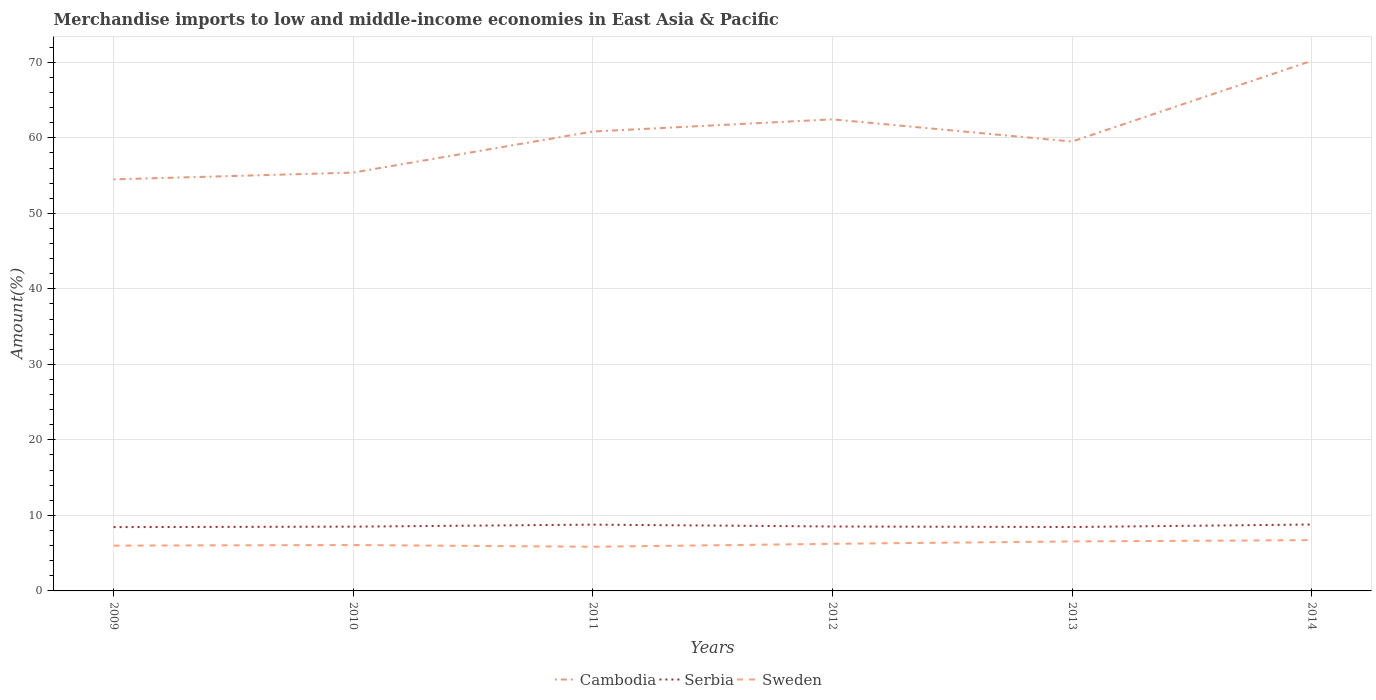How many different coloured lines are there?
Your response must be concise. 3. Is the number of lines equal to the number of legend labels?
Offer a terse response. Yes. Across all years, what is the maximum percentage of amount earned from merchandise imports in Sweden?
Make the answer very short. 5.85. What is the total percentage of amount earned from merchandise imports in Serbia in the graph?
Offer a very short reply. 0.32. What is the difference between the highest and the second highest percentage of amount earned from merchandise imports in Serbia?
Your answer should be very brief. 0.34. What is the difference between the highest and the lowest percentage of amount earned from merchandise imports in Sweden?
Your answer should be very brief. 2. Is the percentage of amount earned from merchandise imports in Serbia strictly greater than the percentage of amount earned from merchandise imports in Sweden over the years?
Ensure brevity in your answer.  No. What is the difference between two consecutive major ticks on the Y-axis?
Ensure brevity in your answer.  10. Are the values on the major ticks of Y-axis written in scientific E-notation?
Provide a short and direct response. No. Does the graph contain any zero values?
Provide a short and direct response. No. Does the graph contain grids?
Provide a short and direct response. Yes. Where does the legend appear in the graph?
Ensure brevity in your answer.  Bottom center. What is the title of the graph?
Your answer should be very brief. Merchandise imports to low and middle-income economies in East Asia & Pacific. Does "Sub-Saharan Africa (all income levels)" appear as one of the legend labels in the graph?
Give a very brief answer. No. What is the label or title of the X-axis?
Provide a succinct answer. Years. What is the label or title of the Y-axis?
Provide a short and direct response. Amount(%). What is the Amount(%) of Cambodia in 2009?
Provide a short and direct response. 54.5. What is the Amount(%) in Serbia in 2009?
Ensure brevity in your answer.  8.45. What is the Amount(%) of Sweden in 2009?
Your answer should be compact. 6. What is the Amount(%) in Cambodia in 2010?
Provide a short and direct response. 55.4. What is the Amount(%) in Serbia in 2010?
Give a very brief answer. 8.51. What is the Amount(%) in Sweden in 2010?
Keep it short and to the point. 6.08. What is the Amount(%) of Cambodia in 2011?
Ensure brevity in your answer.  60.83. What is the Amount(%) in Serbia in 2011?
Make the answer very short. 8.78. What is the Amount(%) of Sweden in 2011?
Make the answer very short. 5.85. What is the Amount(%) of Cambodia in 2012?
Your answer should be compact. 62.45. What is the Amount(%) of Serbia in 2012?
Offer a terse response. 8.53. What is the Amount(%) in Sweden in 2012?
Keep it short and to the point. 6.24. What is the Amount(%) in Cambodia in 2013?
Provide a succinct answer. 59.5. What is the Amount(%) of Serbia in 2013?
Your answer should be compact. 8.46. What is the Amount(%) in Sweden in 2013?
Your response must be concise. 6.55. What is the Amount(%) of Cambodia in 2014?
Your response must be concise. 70.19. What is the Amount(%) of Serbia in 2014?
Offer a very short reply. 8.79. What is the Amount(%) of Sweden in 2014?
Provide a short and direct response. 6.72. Across all years, what is the maximum Amount(%) of Cambodia?
Offer a terse response. 70.19. Across all years, what is the maximum Amount(%) of Serbia?
Make the answer very short. 8.79. Across all years, what is the maximum Amount(%) in Sweden?
Keep it short and to the point. 6.72. Across all years, what is the minimum Amount(%) of Cambodia?
Your response must be concise. 54.5. Across all years, what is the minimum Amount(%) of Serbia?
Your answer should be very brief. 8.45. Across all years, what is the minimum Amount(%) of Sweden?
Give a very brief answer. 5.85. What is the total Amount(%) in Cambodia in the graph?
Provide a short and direct response. 362.88. What is the total Amount(%) in Serbia in the graph?
Keep it short and to the point. 51.53. What is the total Amount(%) of Sweden in the graph?
Provide a succinct answer. 37.44. What is the difference between the Amount(%) of Cambodia in 2009 and that in 2010?
Provide a succinct answer. -0.9. What is the difference between the Amount(%) of Serbia in 2009 and that in 2010?
Keep it short and to the point. -0.06. What is the difference between the Amount(%) of Sweden in 2009 and that in 2010?
Make the answer very short. -0.08. What is the difference between the Amount(%) of Cambodia in 2009 and that in 2011?
Give a very brief answer. -6.33. What is the difference between the Amount(%) in Serbia in 2009 and that in 2011?
Provide a short and direct response. -0.33. What is the difference between the Amount(%) of Sweden in 2009 and that in 2011?
Make the answer very short. 0.15. What is the difference between the Amount(%) in Cambodia in 2009 and that in 2012?
Provide a short and direct response. -7.95. What is the difference between the Amount(%) in Serbia in 2009 and that in 2012?
Ensure brevity in your answer.  -0.08. What is the difference between the Amount(%) in Sweden in 2009 and that in 2012?
Give a very brief answer. -0.24. What is the difference between the Amount(%) of Cambodia in 2009 and that in 2013?
Offer a terse response. -5.01. What is the difference between the Amount(%) in Serbia in 2009 and that in 2013?
Your answer should be very brief. -0.01. What is the difference between the Amount(%) in Sweden in 2009 and that in 2013?
Offer a terse response. -0.55. What is the difference between the Amount(%) in Cambodia in 2009 and that in 2014?
Give a very brief answer. -15.69. What is the difference between the Amount(%) of Serbia in 2009 and that in 2014?
Keep it short and to the point. -0.34. What is the difference between the Amount(%) of Sweden in 2009 and that in 2014?
Provide a succinct answer. -0.72. What is the difference between the Amount(%) in Cambodia in 2010 and that in 2011?
Your answer should be very brief. -5.44. What is the difference between the Amount(%) of Serbia in 2010 and that in 2011?
Offer a very short reply. -0.27. What is the difference between the Amount(%) in Sweden in 2010 and that in 2011?
Offer a terse response. 0.23. What is the difference between the Amount(%) of Cambodia in 2010 and that in 2012?
Offer a very short reply. -7.05. What is the difference between the Amount(%) in Serbia in 2010 and that in 2012?
Your response must be concise. -0.02. What is the difference between the Amount(%) of Sweden in 2010 and that in 2012?
Provide a succinct answer. -0.16. What is the difference between the Amount(%) of Cambodia in 2010 and that in 2013?
Give a very brief answer. -4.11. What is the difference between the Amount(%) of Serbia in 2010 and that in 2013?
Ensure brevity in your answer.  0.05. What is the difference between the Amount(%) in Sweden in 2010 and that in 2013?
Offer a terse response. -0.48. What is the difference between the Amount(%) in Cambodia in 2010 and that in 2014?
Your answer should be very brief. -14.79. What is the difference between the Amount(%) in Serbia in 2010 and that in 2014?
Offer a very short reply. -0.28. What is the difference between the Amount(%) of Sweden in 2010 and that in 2014?
Ensure brevity in your answer.  -0.65. What is the difference between the Amount(%) of Cambodia in 2011 and that in 2012?
Ensure brevity in your answer.  -1.62. What is the difference between the Amount(%) of Serbia in 2011 and that in 2012?
Offer a terse response. 0.25. What is the difference between the Amount(%) in Sweden in 2011 and that in 2012?
Keep it short and to the point. -0.39. What is the difference between the Amount(%) in Cambodia in 2011 and that in 2013?
Ensure brevity in your answer.  1.33. What is the difference between the Amount(%) in Serbia in 2011 and that in 2013?
Your answer should be compact. 0.32. What is the difference between the Amount(%) in Sweden in 2011 and that in 2013?
Offer a very short reply. -0.71. What is the difference between the Amount(%) of Cambodia in 2011 and that in 2014?
Make the answer very short. -9.36. What is the difference between the Amount(%) in Serbia in 2011 and that in 2014?
Give a very brief answer. -0.01. What is the difference between the Amount(%) in Sweden in 2011 and that in 2014?
Make the answer very short. -0.87. What is the difference between the Amount(%) of Cambodia in 2012 and that in 2013?
Your response must be concise. 2.94. What is the difference between the Amount(%) in Serbia in 2012 and that in 2013?
Ensure brevity in your answer.  0.07. What is the difference between the Amount(%) in Sweden in 2012 and that in 2013?
Make the answer very short. -0.32. What is the difference between the Amount(%) of Cambodia in 2012 and that in 2014?
Provide a short and direct response. -7.74. What is the difference between the Amount(%) in Serbia in 2012 and that in 2014?
Your answer should be compact. -0.26. What is the difference between the Amount(%) in Sweden in 2012 and that in 2014?
Give a very brief answer. -0.48. What is the difference between the Amount(%) in Cambodia in 2013 and that in 2014?
Provide a short and direct response. -10.69. What is the difference between the Amount(%) of Serbia in 2013 and that in 2014?
Your answer should be compact. -0.33. What is the difference between the Amount(%) in Sweden in 2013 and that in 2014?
Provide a short and direct response. -0.17. What is the difference between the Amount(%) in Cambodia in 2009 and the Amount(%) in Serbia in 2010?
Ensure brevity in your answer.  45.99. What is the difference between the Amount(%) of Cambodia in 2009 and the Amount(%) of Sweden in 2010?
Provide a short and direct response. 48.42. What is the difference between the Amount(%) of Serbia in 2009 and the Amount(%) of Sweden in 2010?
Offer a very short reply. 2.37. What is the difference between the Amount(%) of Cambodia in 2009 and the Amount(%) of Serbia in 2011?
Your response must be concise. 45.72. What is the difference between the Amount(%) in Cambodia in 2009 and the Amount(%) in Sweden in 2011?
Offer a terse response. 48.65. What is the difference between the Amount(%) in Serbia in 2009 and the Amount(%) in Sweden in 2011?
Keep it short and to the point. 2.6. What is the difference between the Amount(%) in Cambodia in 2009 and the Amount(%) in Serbia in 2012?
Provide a succinct answer. 45.97. What is the difference between the Amount(%) of Cambodia in 2009 and the Amount(%) of Sweden in 2012?
Provide a succinct answer. 48.26. What is the difference between the Amount(%) in Serbia in 2009 and the Amount(%) in Sweden in 2012?
Your answer should be very brief. 2.21. What is the difference between the Amount(%) of Cambodia in 2009 and the Amount(%) of Serbia in 2013?
Your answer should be very brief. 46.04. What is the difference between the Amount(%) of Cambodia in 2009 and the Amount(%) of Sweden in 2013?
Your answer should be compact. 47.95. What is the difference between the Amount(%) in Serbia in 2009 and the Amount(%) in Sweden in 2013?
Your response must be concise. 1.9. What is the difference between the Amount(%) of Cambodia in 2009 and the Amount(%) of Serbia in 2014?
Offer a very short reply. 45.71. What is the difference between the Amount(%) in Cambodia in 2009 and the Amount(%) in Sweden in 2014?
Your answer should be compact. 47.78. What is the difference between the Amount(%) of Serbia in 2009 and the Amount(%) of Sweden in 2014?
Your answer should be very brief. 1.73. What is the difference between the Amount(%) of Cambodia in 2010 and the Amount(%) of Serbia in 2011?
Provide a short and direct response. 46.62. What is the difference between the Amount(%) in Cambodia in 2010 and the Amount(%) in Sweden in 2011?
Provide a succinct answer. 49.55. What is the difference between the Amount(%) of Serbia in 2010 and the Amount(%) of Sweden in 2011?
Provide a succinct answer. 2.66. What is the difference between the Amount(%) of Cambodia in 2010 and the Amount(%) of Serbia in 2012?
Give a very brief answer. 46.87. What is the difference between the Amount(%) of Cambodia in 2010 and the Amount(%) of Sweden in 2012?
Provide a succinct answer. 49.16. What is the difference between the Amount(%) of Serbia in 2010 and the Amount(%) of Sweden in 2012?
Your answer should be very brief. 2.27. What is the difference between the Amount(%) of Cambodia in 2010 and the Amount(%) of Serbia in 2013?
Offer a terse response. 46.93. What is the difference between the Amount(%) in Cambodia in 2010 and the Amount(%) in Sweden in 2013?
Ensure brevity in your answer.  48.84. What is the difference between the Amount(%) of Serbia in 2010 and the Amount(%) of Sweden in 2013?
Ensure brevity in your answer.  1.96. What is the difference between the Amount(%) of Cambodia in 2010 and the Amount(%) of Serbia in 2014?
Your answer should be very brief. 46.6. What is the difference between the Amount(%) of Cambodia in 2010 and the Amount(%) of Sweden in 2014?
Keep it short and to the point. 48.67. What is the difference between the Amount(%) in Serbia in 2010 and the Amount(%) in Sweden in 2014?
Offer a very short reply. 1.79. What is the difference between the Amount(%) of Cambodia in 2011 and the Amount(%) of Serbia in 2012?
Offer a terse response. 52.3. What is the difference between the Amount(%) in Cambodia in 2011 and the Amount(%) in Sweden in 2012?
Your answer should be compact. 54.6. What is the difference between the Amount(%) in Serbia in 2011 and the Amount(%) in Sweden in 2012?
Make the answer very short. 2.54. What is the difference between the Amount(%) in Cambodia in 2011 and the Amount(%) in Serbia in 2013?
Give a very brief answer. 52.37. What is the difference between the Amount(%) in Cambodia in 2011 and the Amount(%) in Sweden in 2013?
Make the answer very short. 54.28. What is the difference between the Amount(%) of Serbia in 2011 and the Amount(%) of Sweden in 2013?
Provide a succinct answer. 2.22. What is the difference between the Amount(%) of Cambodia in 2011 and the Amount(%) of Serbia in 2014?
Your answer should be compact. 52.04. What is the difference between the Amount(%) in Cambodia in 2011 and the Amount(%) in Sweden in 2014?
Ensure brevity in your answer.  54.11. What is the difference between the Amount(%) of Serbia in 2011 and the Amount(%) of Sweden in 2014?
Give a very brief answer. 2.06. What is the difference between the Amount(%) of Cambodia in 2012 and the Amount(%) of Serbia in 2013?
Give a very brief answer. 53.99. What is the difference between the Amount(%) of Cambodia in 2012 and the Amount(%) of Sweden in 2013?
Your answer should be compact. 55.9. What is the difference between the Amount(%) of Serbia in 2012 and the Amount(%) of Sweden in 2013?
Your answer should be very brief. 1.98. What is the difference between the Amount(%) in Cambodia in 2012 and the Amount(%) in Serbia in 2014?
Provide a short and direct response. 53.66. What is the difference between the Amount(%) in Cambodia in 2012 and the Amount(%) in Sweden in 2014?
Provide a succinct answer. 55.73. What is the difference between the Amount(%) in Serbia in 2012 and the Amount(%) in Sweden in 2014?
Offer a terse response. 1.81. What is the difference between the Amount(%) in Cambodia in 2013 and the Amount(%) in Serbia in 2014?
Your response must be concise. 50.71. What is the difference between the Amount(%) in Cambodia in 2013 and the Amount(%) in Sweden in 2014?
Offer a terse response. 52.78. What is the difference between the Amount(%) in Serbia in 2013 and the Amount(%) in Sweden in 2014?
Your answer should be very brief. 1.74. What is the average Amount(%) of Cambodia per year?
Give a very brief answer. 60.48. What is the average Amount(%) in Serbia per year?
Provide a short and direct response. 8.59. What is the average Amount(%) of Sweden per year?
Your answer should be very brief. 6.24. In the year 2009, what is the difference between the Amount(%) in Cambodia and Amount(%) in Serbia?
Make the answer very short. 46.05. In the year 2009, what is the difference between the Amount(%) in Cambodia and Amount(%) in Sweden?
Your answer should be very brief. 48.5. In the year 2009, what is the difference between the Amount(%) in Serbia and Amount(%) in Sweden?
Provide a short and direct response. 2.45. In the year 2010, what is the difference between the Amount(%) in Cambodia and Amount(%) in Serbia?
Offer a very short reply. 46.88. In the year 2010, what is the difference between the Amount(%) of Cambodia and Amount(%) of Sweden?
Your answer should be compact. 49.32. In the year 2010, what is the difference between the Amount(%) in Serbia and Amount(%) in Sweden?
Keep it short and to the point. 2.43. In the year 2011, what is the difference between the Amount(%) in Cambodia and Amount(%) in Serbia?
Give a very brief answer. 52.05. In the year 2011, what is the difference between the Amount(%) in Cambodia and Amount(%) in Sweden?
Provide a short and direct response. 54.99. In the year 2011, what is the difference between the Amount(%) in Serbia and Amount(%) in Sweden?
Offer a terse response. 2.93. In the year 2012, what is the difference between the Amount(%) in Cambodia and Amount(%) in Serbia?
Ensure brevity in your answer.  53.92. In the year 2012, what is the difference between the Amount(%) in Cambodia and Amount(%) in Sweden?
Your response must be concise. 56.21. In the year 2012, what is the difference between the Amount(%) in Serbia and Amount(%) in Sweden?
Your answer should be compact. 2.29. In the year 2013, what is the difference between the Amount(%) in Cambodia and Amount(%) in Serbia?
Ensure brevity in your answer.  51.04. In the year 2013, what is the difference between the Amount(%) in Cambodia and Amount(%) in Sweden?
Offer a very short reply. 52.95. In the year 2013, what is the difference between the Amount(%) in Serbia and Amount(%) in Sweden?
Your answer should be very brief. 1.91. In the year 2014, what is the difference between the Amount(%) in Cambodia and Amount(%) in Serbia?
Your answer should be compact. 61.4. In the year 2014, what is the difference between the Amount(%) of Cambodia and Amount(%) of Sweden?
Give a very brief answer. 63.47. In the year 2014, what is the difference between the Amount(%) of Serbia and Amount(%) of Sweden?
Offer a very short reply. 2.07. What is the ratio of the Amount(%) in Cambodia in 2009 to that in 2010?
Provide a short and direct response. 0.98. What is the ratio of the Amount(%) in Serbia in 2009 to that in 2010?
Ensure brevity in your answer.  0.99. What is the ratio of the Amount(%) of Sweden in 2009 to that in 2010?
Offer a terse response. 0.99. What is the ratio of the Amount(%) of Cambodia in 2009 to that in 2011?
Give a very brief answer. 0.9. What is the ratio of the Amount(%) in Serbia in 2009 to that in 2011?
Your response must be concise. 0.96. What is the ratio of the Amount(%) of Sweden in 2009 to that in 2011?
Give a very brief answer. 1.03. What is the ratio of the Amount(%) of Cambodia in 2009 to that in 2012?
Your answer should be compact. 0.87. What is the ratio of the Amount(%) of Serbia in 2009 to that in 2012?
Provide a short and direct response. 0.99. What is the ratio of the Amount(%) of Sweden in 2009 to that in 2012?
Keep it short and to the point. 0.96. What is the ratio of the Amount(%) of Cambodia in 2009 to that in 2013?
Give a very brief answer. 0.92. What is the ratio of the Amount(%) of Sweden in 2009 to that in 2013?
Offer a terse response. 0.92. What is the ratio of the Amount(%) of Cambodia in 2009 to that in 2014?
Your answer should be compact. 0.78. What is the ratio of the Amount(%) in Serbia in 2009 to that in 2014?
Give a very brief answer. 0.96. What is the ratio of the Amount(%) of Sweden in 2009 to that in 2014?
Your response must be concise. 0.89. What is the ratio of the Amount(%) in Cambodia in 2010 to that in 2011?
Provide a succinct answer. 0.91. What is the ratio of the Amount(%) in Serbia in 2010 to that in 2011?
Your answer should be very brief. 0.97. What is the ratio of the Amount(%) in Sweden in 2010 to that in 2011?
Keep it short and to the point. 1.04. What is the ratio of the Amount(%) of Cambodia in 2010 to that in 2012?
Offer a terse response. 0.89. What is the ratio of the Amount(%) of Serbia in 2010 to that in 2012?
Your answer should be very brief. 1. What is the ratio of the Amount(%) in Sweden in 2010 to that in 2012?
Your answer should be very brief. 0.97. What is the ratio of the Amount(%) in Cambodia in 2010 to that in 2013?
Provide a short and direct response. 0.93. What is the ratio of the Amount(%) of Serbia in 2010 to that in 2013?
Make the answer very short. 1.01. What is the ratio of the Amount(%) of Sweden in 2010 to that in 2013?
Your response must be concise. 0.93. What is the ratio of the Amount(%) of Cambodia in 2010 to that in 2014?
Make the answer very short. 0.79. What is the ratio of the Amount(%) in Serbia in 2010 to that in 2014?
Provide a succinct answer. 0.97. What is the ratio of the Amount(%) of Sweden in 2010 to that in 2014?
Your response must be concise. 0.9. What is the ratio of the Amount(%) in Cambodia in 2011 to that in 2012?
Offer a terse response. 0.97. What is the ratio of the Amount(%) in Cambodia in 2011 to that in 2013?
Keep it short and to the point. 1.02. What is the ratio of the Amount(%) in Serbia in 2011 to that in 2013?
Your answer should be compact. 1.04. What is the ratio of the Amount(%) in Sweden in 2011 to that in 2013?
Provide a short and direct response. 0.89. What is the ratio of the Amount(%) in Cambodia in 2011 to that in 2014?
Provide a short and direct response. 0.87. What is the ratio of the Amount(%) in Serbia in 2011 to that in 2014?
Provide a succinct answer. 1. What is the ratio of the Amount(%) of Sweden in 2011 to that in 2014?
Your response must be concise. 0.87. What is the ratio of the Amount(%) of Cambodia in 2012 to that in 2013?
Your answer should be compact. 1.05. What is the ratio of the Amount(%) in Serbia in 2012 to that in 2013?
Keep it short and to the point. 1.01. What is the ratio of the Amount(%) of Sweden in 2012 to that in 2013?
Keep it short and to the point. 0.95. What is the ratio of the Amount(%) in Cambodia in 2012 to that in 2014?
Your answer should be compact. 0.89. What is the ratio of the Amount(%) in Serbia in 2012 to that in 2014?
Your response must be concise. 0.97. What is the ratio of the Amount(%) in Sweden in 2012 to that in 2014?
Give a very brief answer. 0.93. What is the ratio of the Amount(%) of Cambodia in 2013 to that in 2014?
Keep it short and to the point. 0.85. What is the ratio of the Amount(%) in Serbia in 2013 to that in 2014?
Offer a very short reply. 0.96. What is the ratio of the Amount(%) in Sweden in 2013 to that in 2014?
Keep it short and to the point. 0.97. What is the difference between the highest and the second highest Amount(%) of Cambodia?
Offer a terse response. 7.74. What is the difference between the highest and the second highest Amount(%) of Serbia?
Provide a succinct answer. 0.01. What is the difference between the highest and the second highest Amount(%) of Sweden?
Your response must be concise. 0.17. What is the difference between the highest and the lowest Amount(%) of Cambodia?
Provide a short and direct response. 15.69. What is the difference between the highest and the lowest Amount(%) in Serbia?
Offer a very short reply. 0.34. What is the difference between the highest and the lowest Amount(%) in Sweden?
Your answer should be compact. 0.87. 